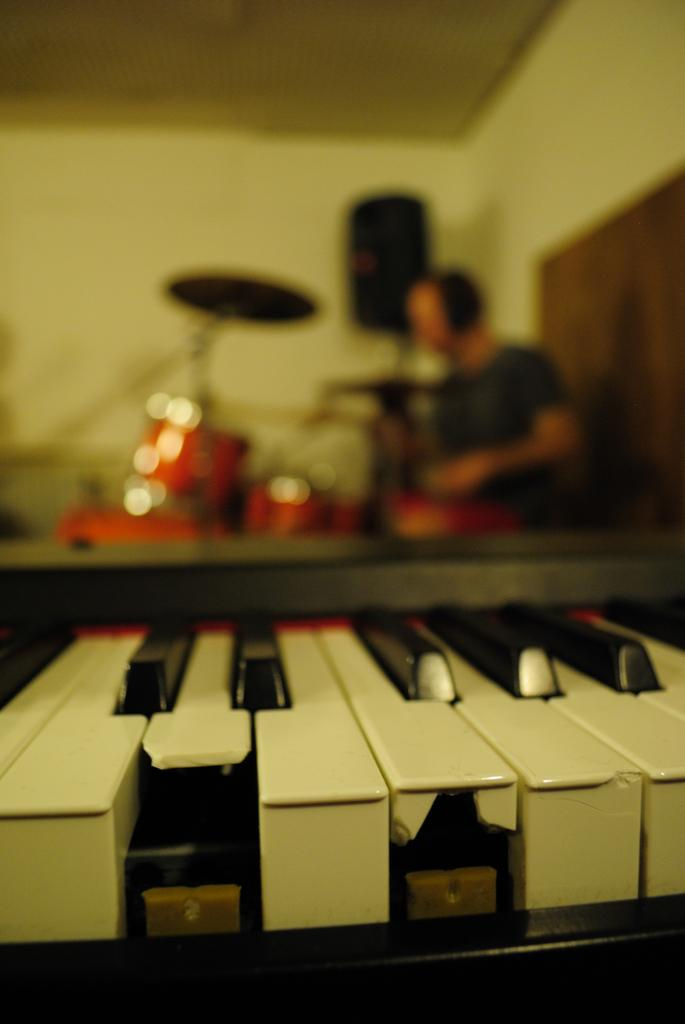What objects are visible in the image? There are keyboard keys in the image. What is the person in the image doing? The person is playing a musical instrument. What can be seen in the background of the image? There is a wall in the background of the image. What type of lettuce is being used as a teaching aid in the image? There is no lettuce present in the image, nor is there any indication of teaching or a teaching aid. 